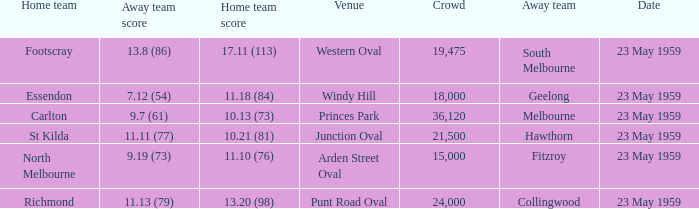What was the home team's score at the game that had a crowd larger than 24,000? 10.13 (73). 